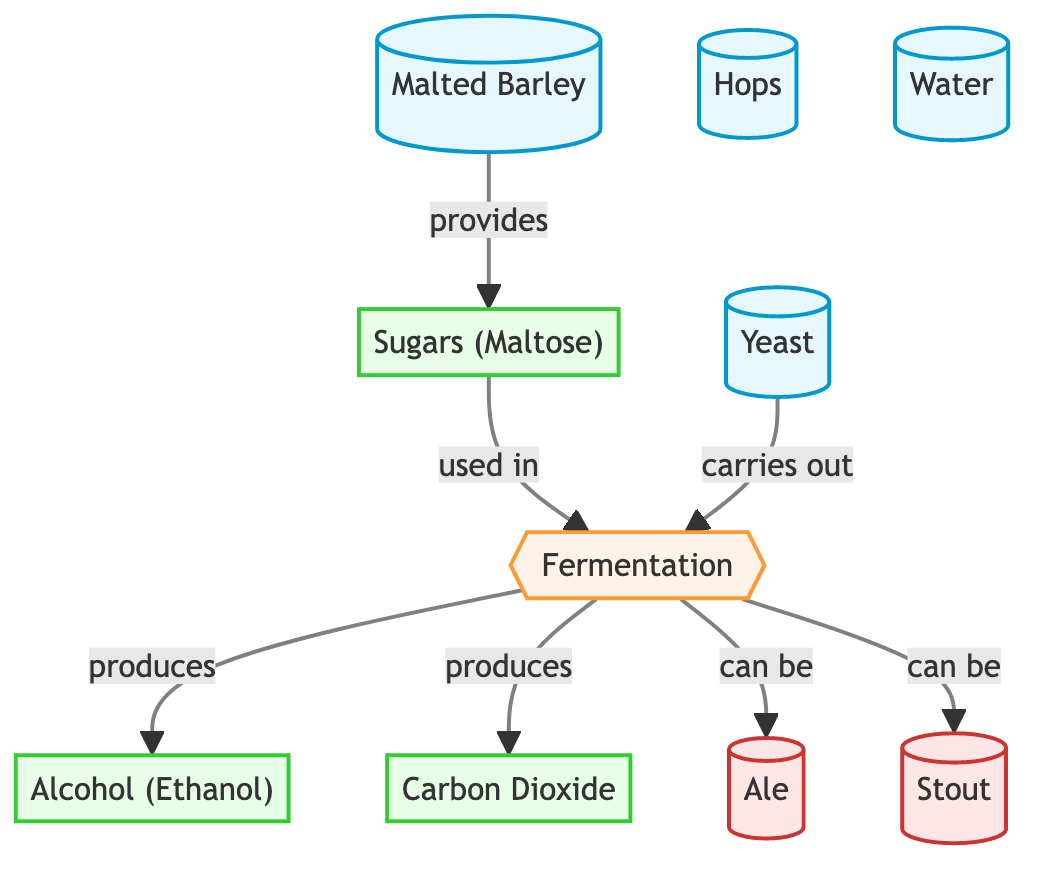What's the first ingredient listed in the diagram? The diagram starts with "Malted Barley" as the first ingredient node.
Answer: Malted Barley How many products are shown in the diagram? The diagram lists three products: Sugars (Maltose), Alcohol (Ethanol), and Carbon Dioxide, totaling three products.
Answer: 3 What process is represented between the ingredients and products? The process that links the ingredients to the products is called "Fermentation," which is indicated at the center of the diagram.
Answer: Fermentation Which ingredient is responsible for producing Alcohol? The "Yeast" ingredient carries out the fermentation process, leading to the production of Alcohol (Ethanol). So, Yeast is responsible for this.
Answer: Yeast What types of beer can be produced from the fermentation process? The diagram indicates that both "Ale" and "Stout" are beer types that can be produced through the fermentation process.
Answer: Ale, Stout Which ingredient contributes sugars for fermentation? The ingredient "Malted Barley" is shown to provide sugars (Maltose) during the fermentation process, supporting the subsequent conversions.
Answer: Malted Barley What gas is produced during fermentation alongside alcohol? The fermentation process generates "Carbon Dioxide" in addition to alcohol, as depicted in the diagram.
Answer: Carbon Dioxide If fermentation is successful, what are the main outputs produced? The outputs from the fermentation process are Sugars (Maltose), Alcohol (Ethanol), and Carbon Dioxide, highlighting the results of fermentation clearly.
Answer: Sugars, Alcohol, Carbon Dioxide 